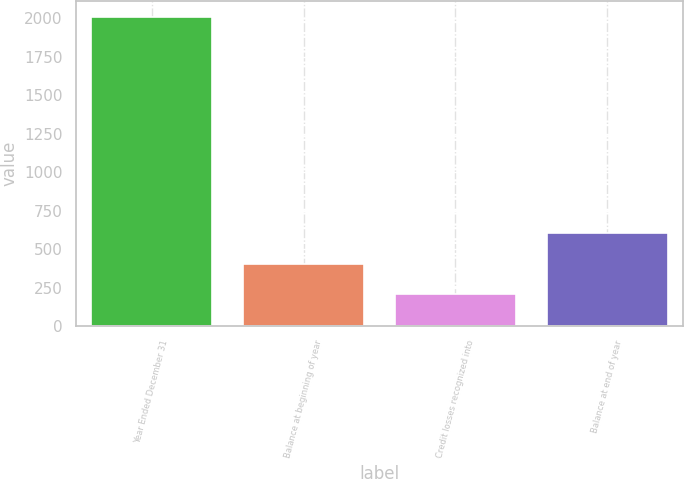Convert chart to OTSL. <chart><loc_0><loc_0><loc_500><loc_500><bar_chart><fcel>Year Ended December 31<fcel>Balance at beginning of year<fcel>Credit losses recognized into<fcel>Balance at end of year<nl><fcel>2012<fcel>407.2<fcel>206.6<fcel>607.8<nl></chart> 